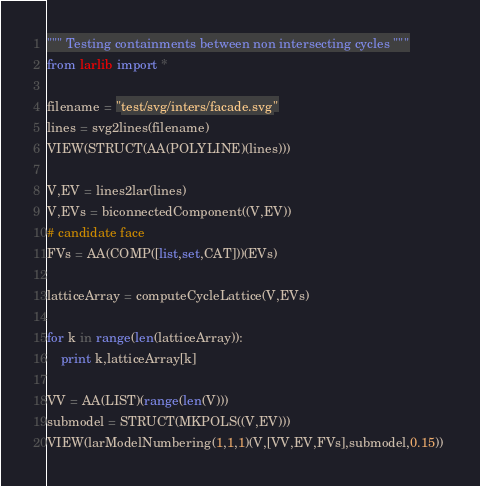<code> <loc_0><loc_0><loc_500><loc_500><_Python_>""" Testing containments between non intersecting cycles """
from larlib import *

filename = "test/svg/inters/facade.svg"
lines = svg2lines(filename)
VIEW(STRUCT(AA(POLYLINE)(lines)))

V,EV = lines2lar(lines)
V,EVs = biconnectedComponent((V,EV))
# candidate face
FVs = AA(COMP([list,set,CAT]))(EVs)

latticeArray = computeCycleLattice(V,EVs)

for k in range(len(latticeArray)):
    print k,latticeArray[k]

VV = AA(LIST)(range(len(V)))
submodel = STRUCT(MKPOLS((V,EV)))
VIEW(larModelNumbering(1,1,1)(V,[VV,EV,FVs],submodel,0.15)) 
</code> 